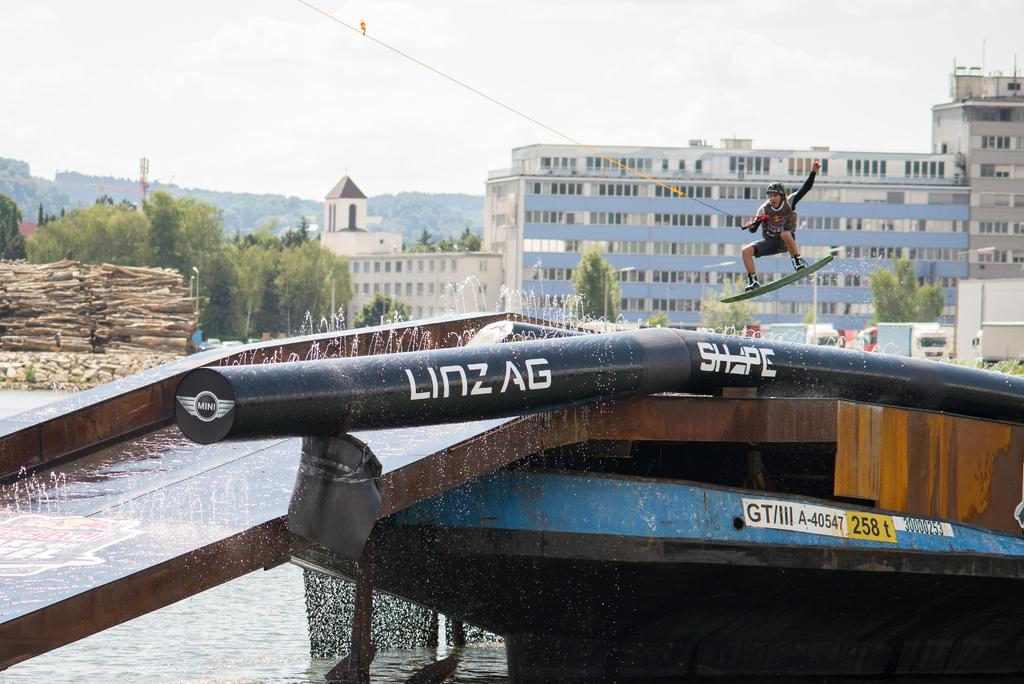<image>
Summarize the visual content of the image. A man in a helmet jumps over a Linzag tube. 